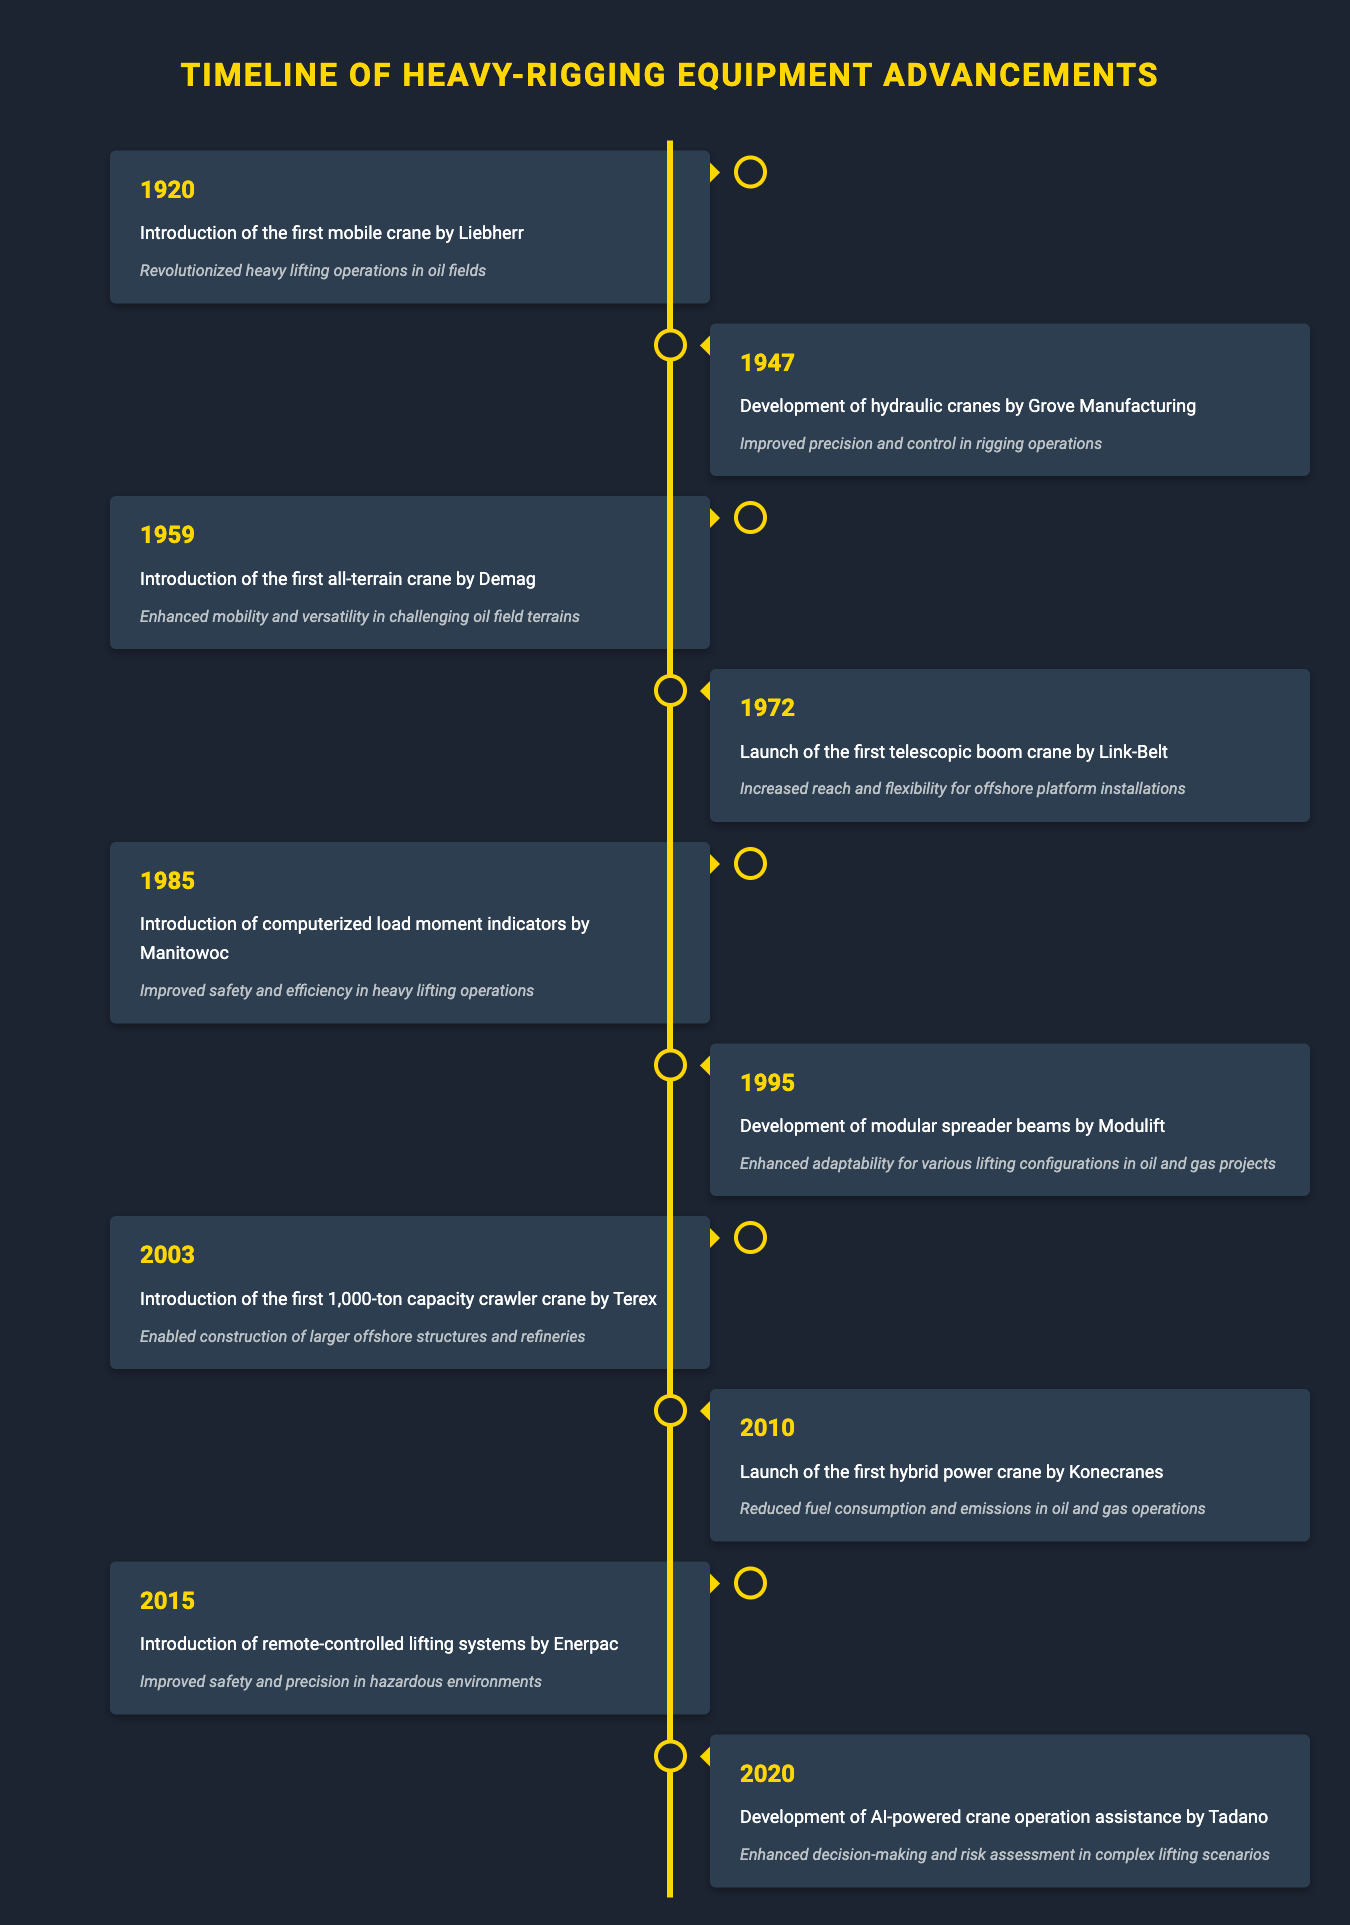What event occurred in 1972? The table lists the event "Launch of the first telescopic boom crane by Link-Belt" that happened in 1972.
Answer: Launch of the first telescopic boom crane by Link-Belt Which company introduced the first mobile crane? The timeline shows that the first mobile crane was introduced by Liebherr in 1920.
Answer: Liebherr Is it true that the introduction of computerized load moment indicators improved safety and efficiency? Yes, according to the table, the introduction of computerized load moment indicators by Manitowoc in 1985 improved safety and efficiency in heavy lifting operations.
Answer: Yes What was the impact of the development of AI-powered crane operation assistance? The impact mentioned in the table is that it enhanced decision-making and risk assessment in complex lifting scenarios.
Answer: Enhanced decision-making and risk assessment Which technological advancement occurred between 1985 and 2003? Referring to the timeline, the advancements were "Introduction of computerized load moment indicators by Manitowoc" in 1985 and "Introduction of the first 1,000-ton capacity crawler crane by Terex" in 2003. Therefore, the development of modular spreader beams by Modulift in 1995 is the advancement that fits this criteria.
Answer: Development of modular spreader beams by Modulift By how many years was the introduction of remote-controlled lifting systems later than the launch of the hybrid power crane? The hybrid power crane was launched in 2010 and remote-controlled lifting systems were introduced in 2015. The difference is 2015 - 2010 = 5 years.
Answer: 5 years What year saw the introduction of the first all-terrain crane, and what was its impact? The first all-terrain crane was introduced in 1959, and its impact was enhanced mobility and versatility in challenging oil field terrains.
Answer: 1959, enhanced mobility and versatility How many significant advancements were made from 1920 to 1972? The table shows 4 advancements during this period: 1920, 1947, 1959, and 1972.
Answer: 4 advancements Which technological advancement had the greatest capacity introduced before 2010? The introduction of the first 1,000-ton capacity crawler crane by Terex in 2003 had the greatest capacity introduced before 2010.
Answer: Introduction of the first 1,000-ton capacity crawler crane by Terex 